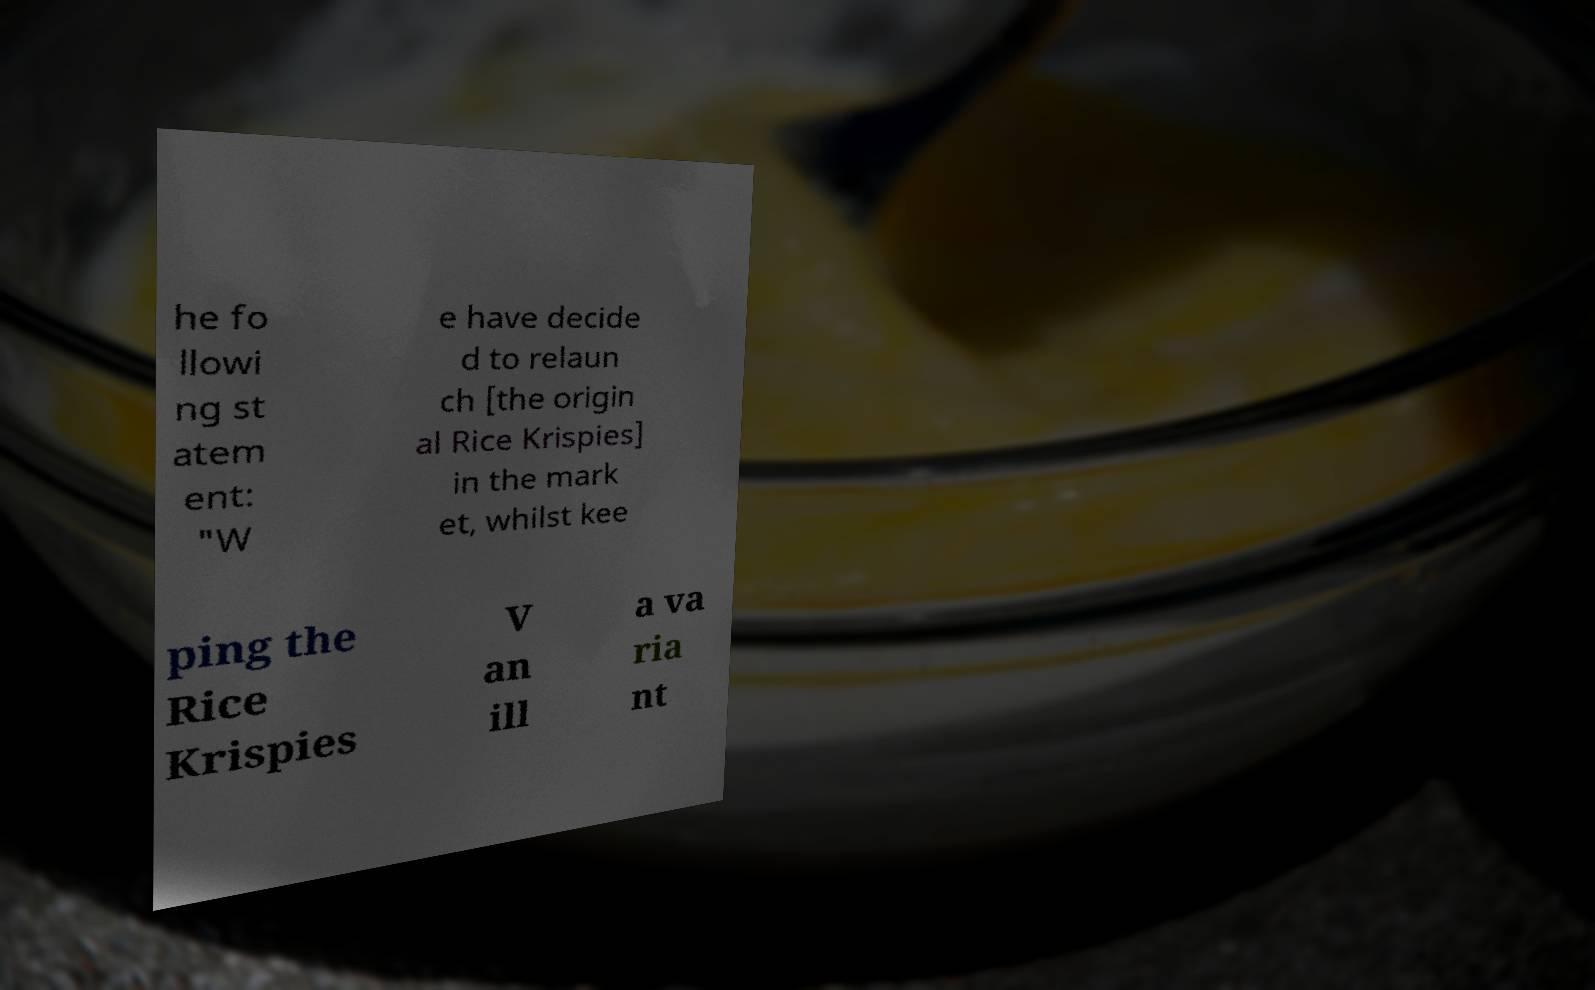What messages or text are displayed in this image? I need them in a readable, typed format. he fo llowi ng st atem ent: "W e have decide d to relaun ch [the origin al Rice Krispies] in the mark et, whilst kee ping the Rice Krispies V an ill a va ria nt 